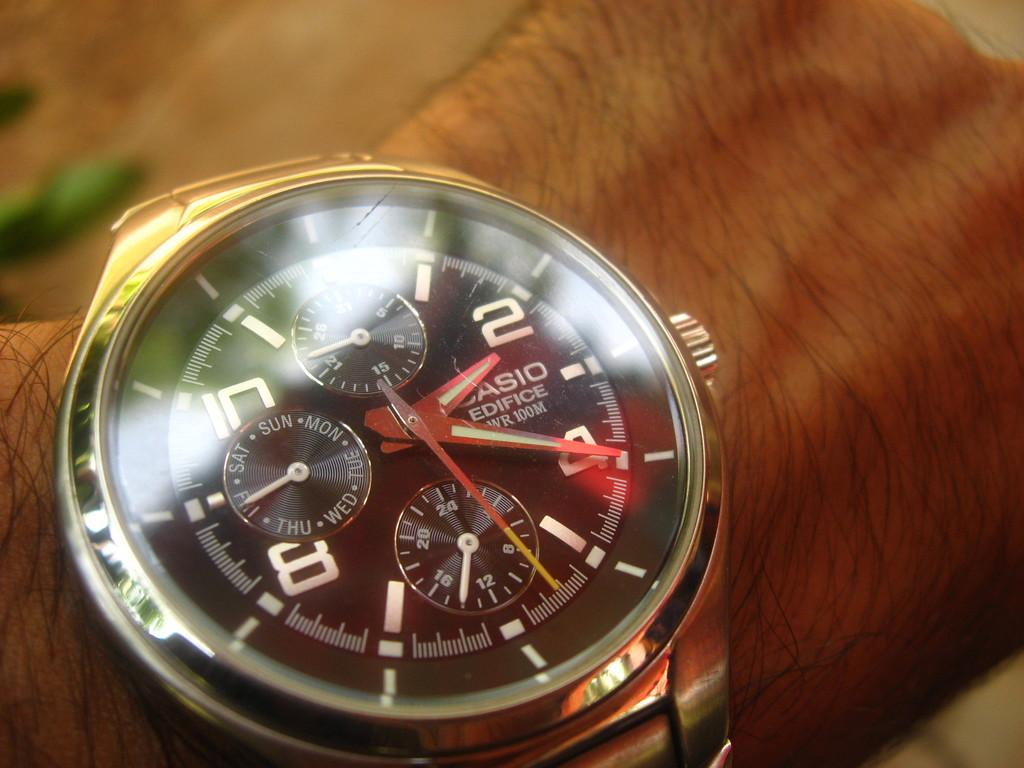What time is it?
Offer a terse response. 2:20. What brand of watch is this?
Provide a succinct answer. Casio. 